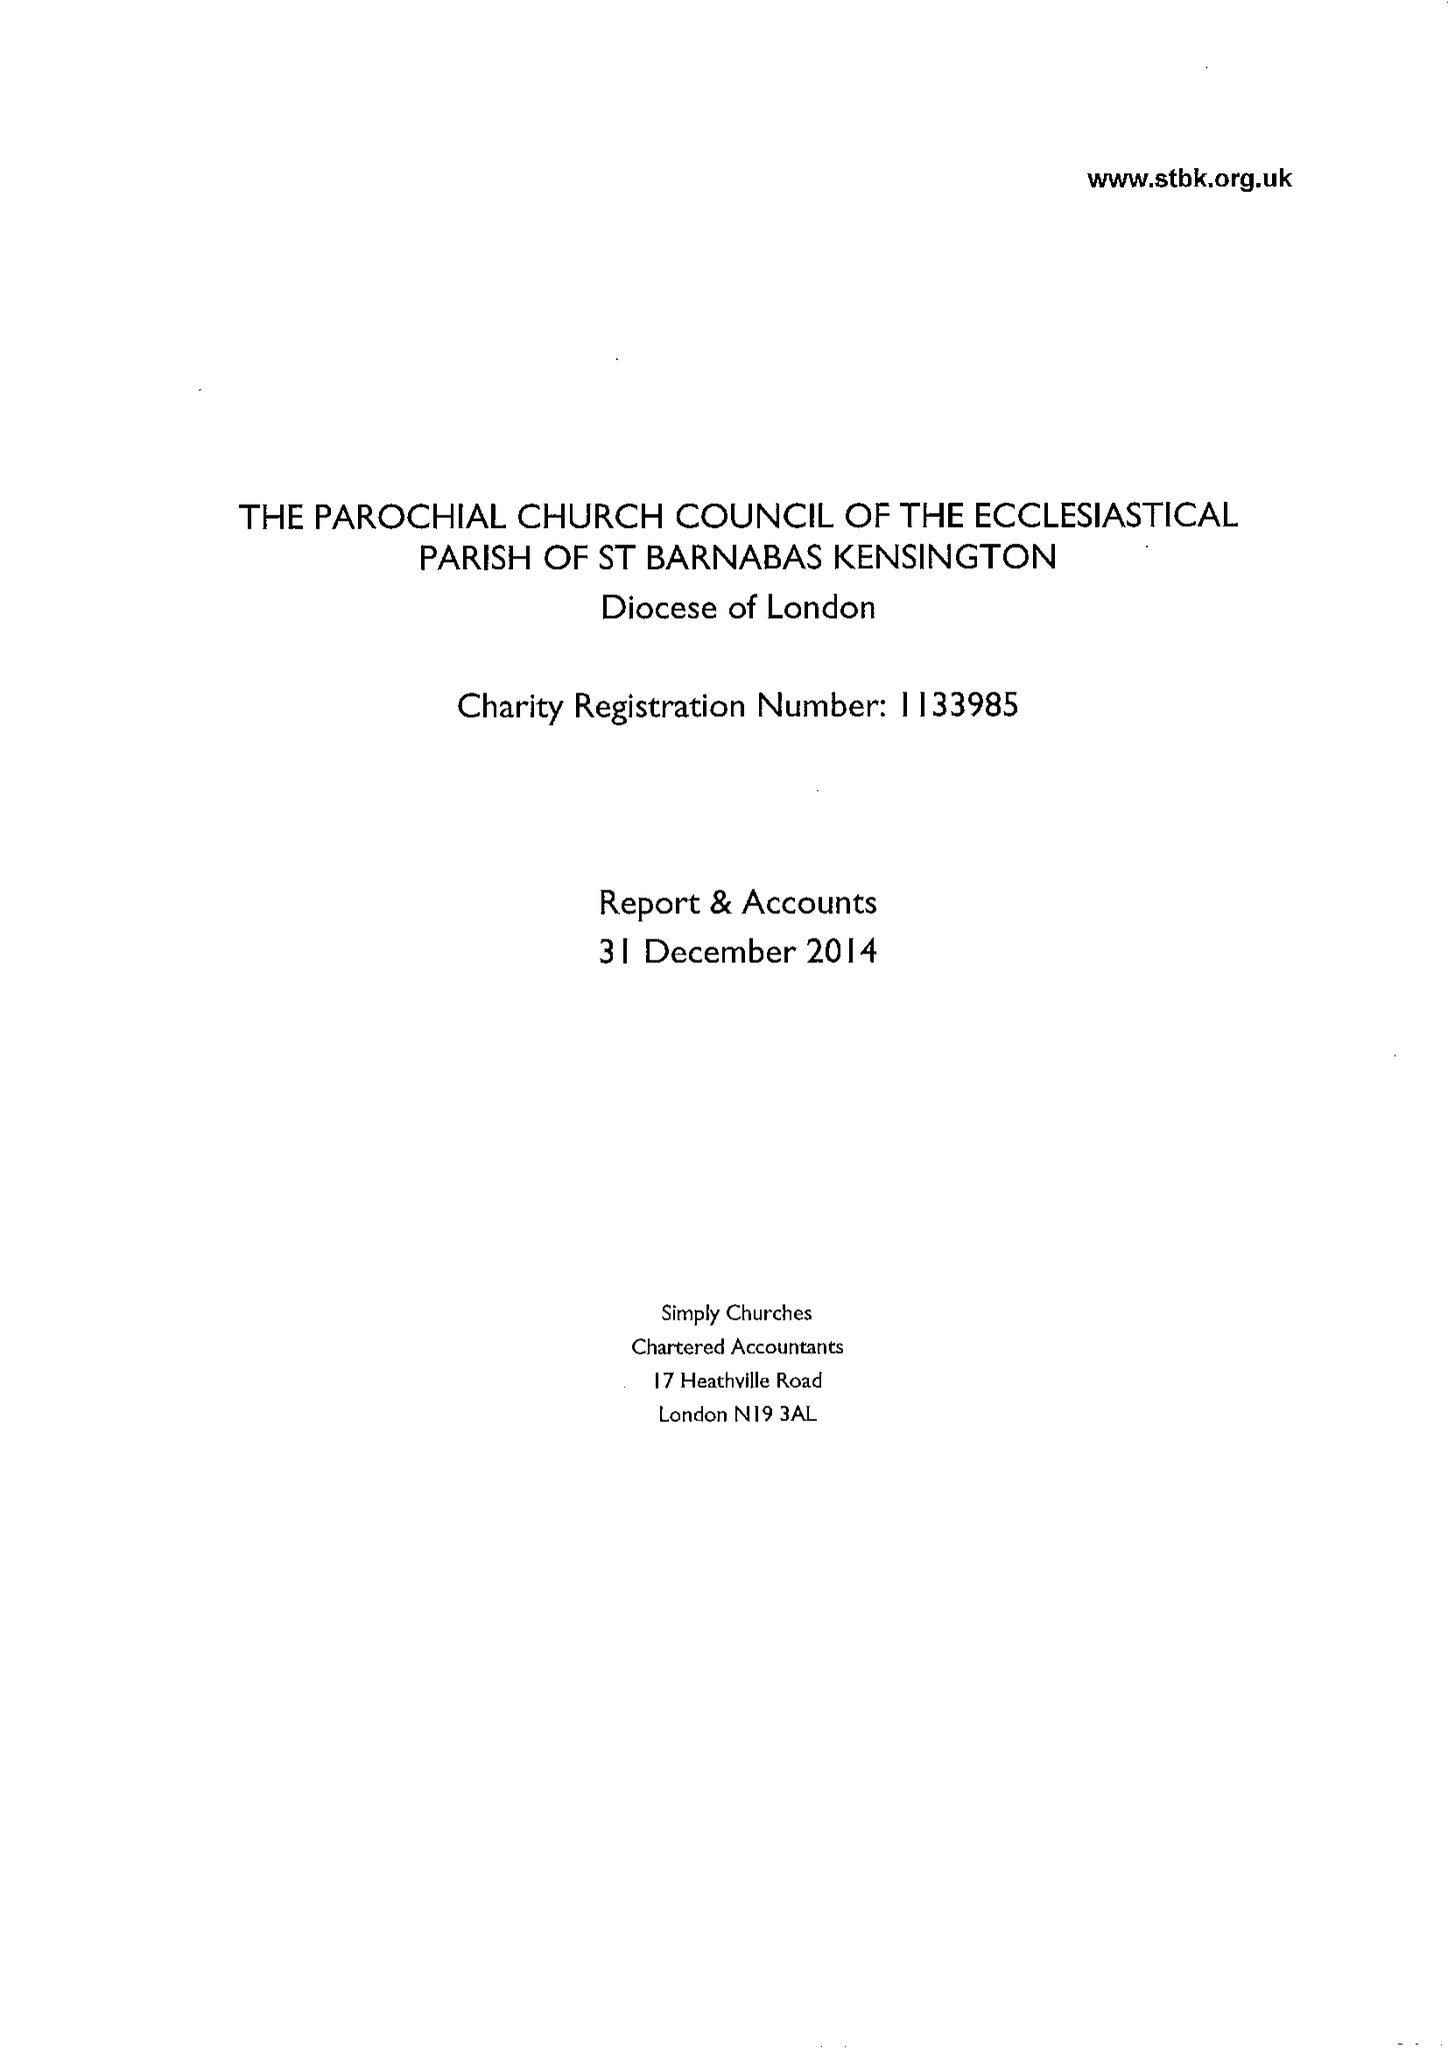What is the value for the spending_annually_in_british_pounds?
Answer the question using a single word or phrase. 477500.00 